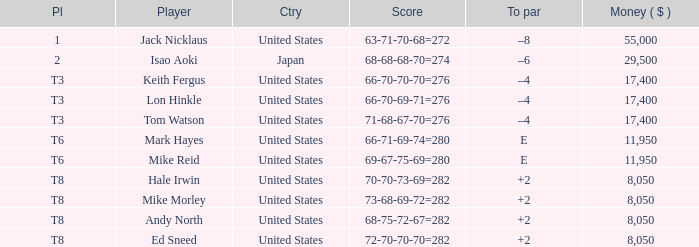What player has money larger than 11,950 and is placed in t8 and has the score of 73-68-69-72=282? None. 